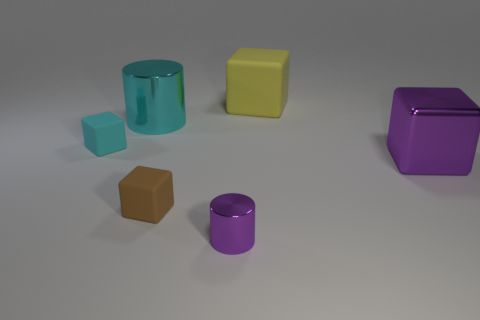Is there any other thing that has the same size as the purple metal cube?
Provide a short and direct response. Yes. There is a purple object that is the same size as the brown matte block; what is its shape?
Offer a very short reply. Cylinder. Are there any yellow matte objects that have the same shape as the tiny purple thing?
Make the answer very short. No. Are there any tiny brown rubber objects that are to the right of the purple thing that is behind the purple metal thing to the left of the large purple object?
Your response must be concise. No. Are there more small shiny cylinders that are behind the cyan matte thing than yellow matte blocks in front of the purple cube?
Make the answer very short. No. There is a purple thing that is the same size as the yellow rubber thing; what is its material?
Your answer should be compact. Metal. How many small objects are either purple cylinders or brown things?
Ensure brevity in your answer.  2. Is the shape of the tiny brown object the same as the small shiny object?
Offer a terse response. No. What number of big metallic objects are behind the cyan block and in front of the cyan block?
Make the answer very short. 0. Is there anything else that has the same color as the large metal cube?
Your answer should be compact. Yes. 